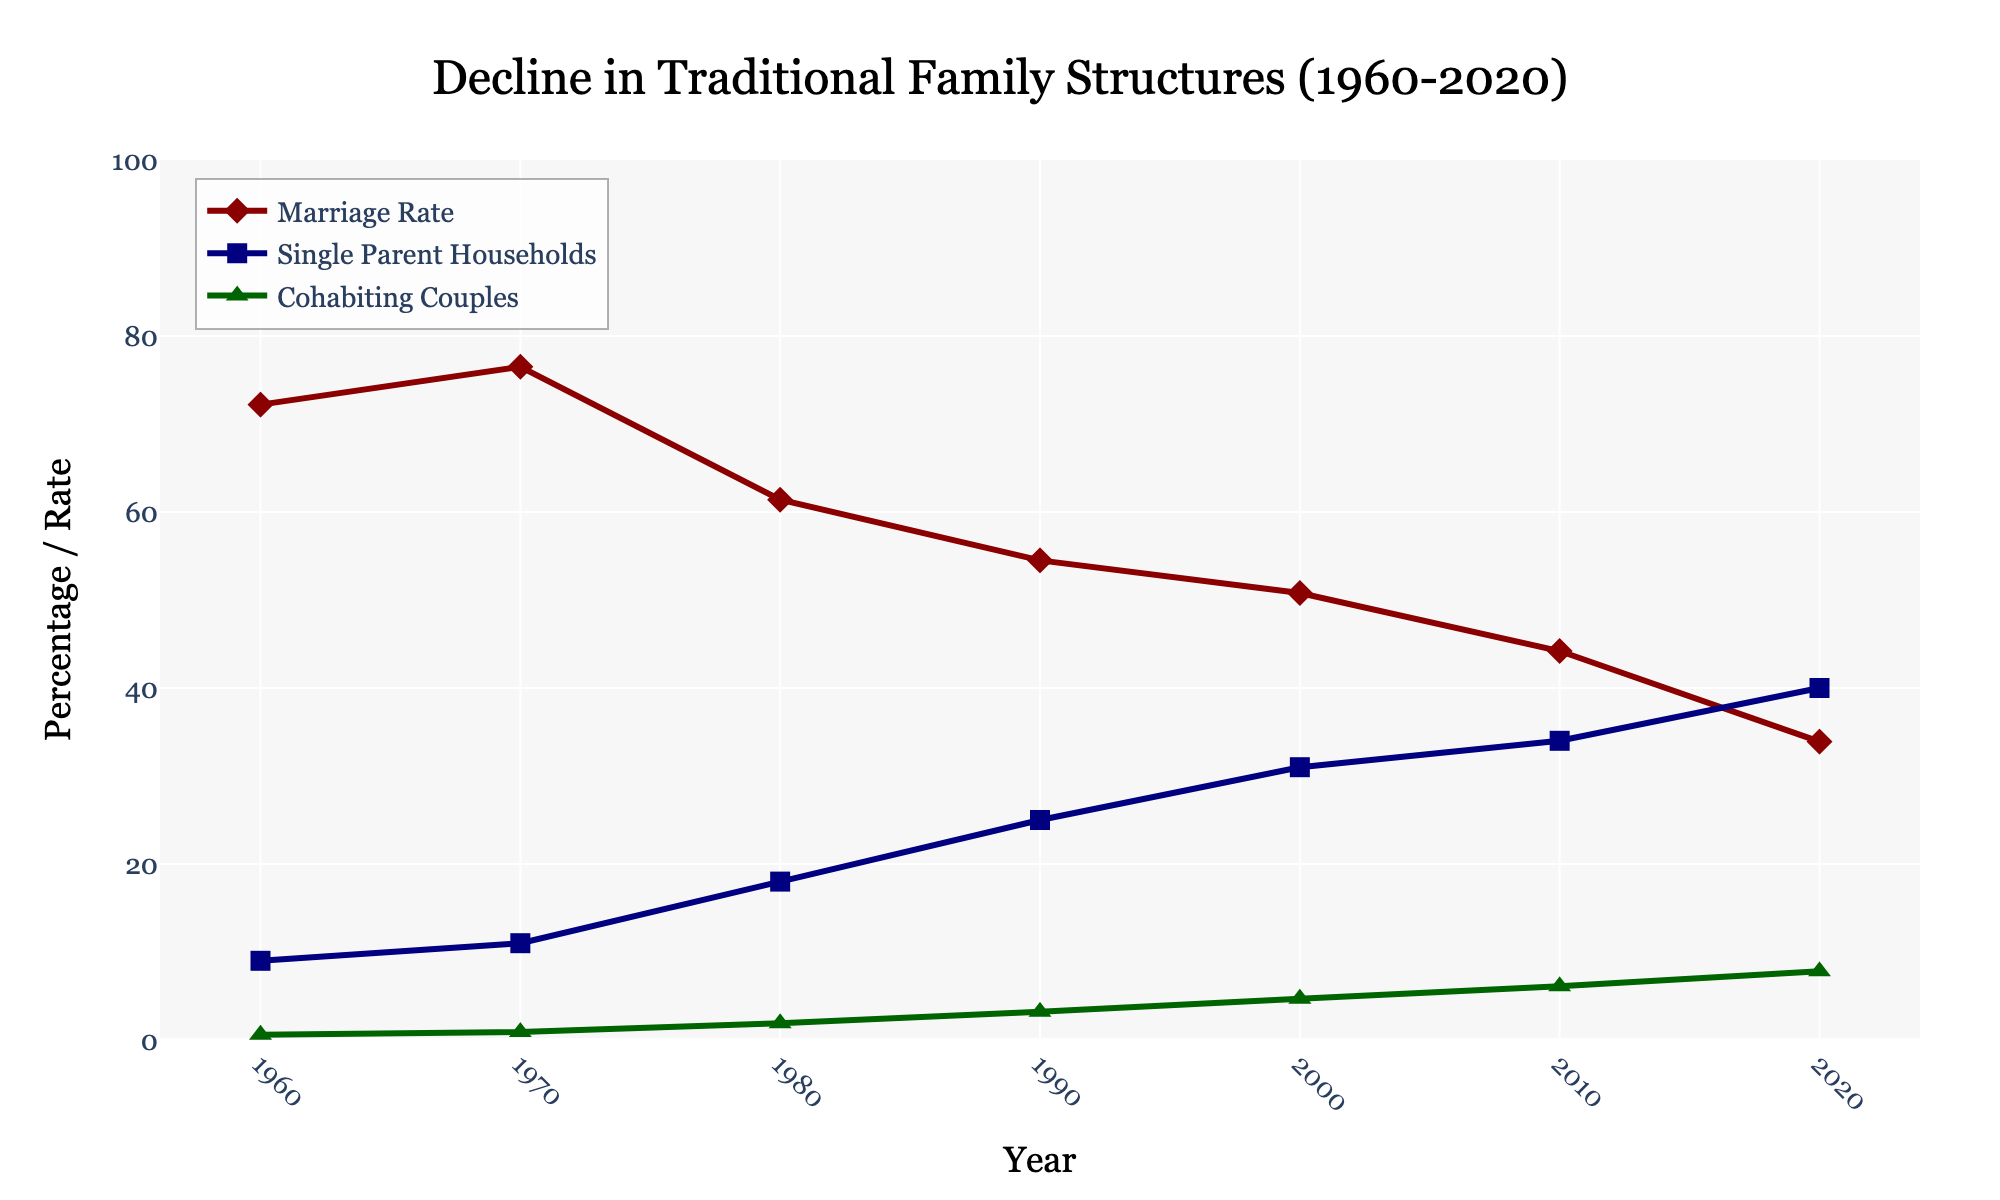What trend is observed in the marriage rate from 1960 to 2020? From the figure, it can be seen that the marriage rate declines consistently over time. In 1960, it is about 72.2 per 1000, and by 2020, it drops to 33.9 per 1000.
Answer: The marriage rate shows a declining trend Which year had the highest percentage of single-parent households? The highest percentage of single-parent households is shown for the year 2020. From the figure, it is evident that the value reaches 40% in that year.
Answer: 2020 How do the percentages of cohabiting couples compare between 1980 and 2000? In 1980, the percentage of cohabiting couples is 1.9%, while in 2000, it increases to 4.7%. Comparing these figures, cohabiting couples increased by 2.8 percentage points over this period.
Answer: Cohabiting couples increased by 2.8 percentage points By how many percentage points did the rate of single-parent households change from 1990 to 2020? In 1990, the percentage of single-parent households is 25%. By 2020, it increases to 40%. The change is calculated as 40% - 25% = 15%.
Answer: Increased by 15 percentage points Which demographic, single-parent households or cohabiting couples, had a steeper increase between 1960 and 2020? From the figure, single-parent households increased from 9% to 40%, which is a 31 percentage point increase. Cohabiting couples increased from 0.6% to 7.8%, which is a 7.2 percentage point increase. Comparing these increases, single-parent households had a steeper rise.
Answer: Single-parent households In what decade did the marriage rate experience the largest drop? Observing the figure, the marriage rate dropped from 76.5 per 1000 in 1970 to 54.5 per 1000 in 1990. This is a drop of 22 per 1000. No other decade shows as large a decrease.
Answer: Between 1970 and 1990 What visual attributes are used to differentiate the three categories in the figure, and how do these visuals help interpret the data? Different line colors (dark red for marriage rate, navy for single-parent households, dark green for cohabiting couples) and marker shapes (diamond for marriage rate, square for single-parent households, triangle for cohabiting couples) are used. These visual attributes allow easy differentiation and help in quick comparison of trends.
Answer: Colors and shapes How did the marriage rate and single-parent households change between 2000 and 2010? The marriage rate decreased from 50.8 to 44.2 per 1000 (a drop of 6.6 per 1000), while single-parent households increased from 31% to 34% (an increase of 3 percentage points).
Answer: Marriage rate decreased, single-parent households increased Over the entire period shown in the figure, which category experienced the least change in percentage terms? The category of cohabiting couples started at 0.6% in 1960 and ended at 7.8% in 2020, which is a change of 7.2 percentage points. This is the smallest change compared to marriage rates and single-parent households.
Answer: Cohabiting couples What can be inferred about the stability of traditional family structures based on the trends shown in the figure? The declining marriage rate and the rising percentage of single-parent households and cohabiting couples indicate that traditional family structures have become less stable and less common over time.
Answer: Traditional family structures have become less stable 